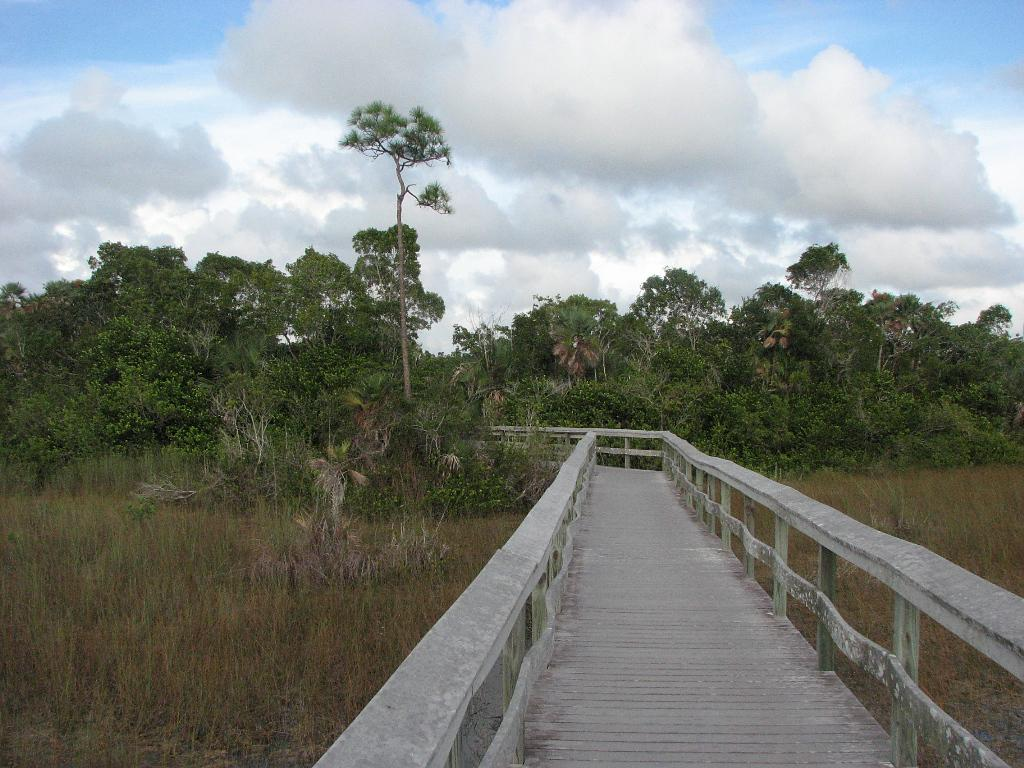What is the main feature in the center of the image? There is a walkway in the center of the image. What type of vegetation is present at the bottom of the image? There is grass at the bottom of the image. What can be seen in the background of the image? There are trees and the sky visible in the background of the image. What arithmetic problem is being solved by the passenger in the image? There is no passenger or arithmetic problem present in the image. 